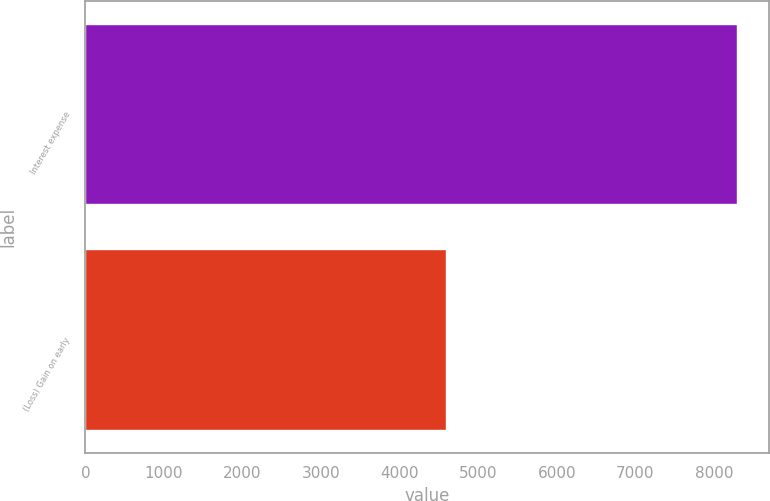<chart> <loc_0><loc_0><loc_500><loc_500><bar_chart><fcel>Interest expense<fcel>(Loss) Gain on early<nl><fcel>8290<fcel>4590<nl></chart> 